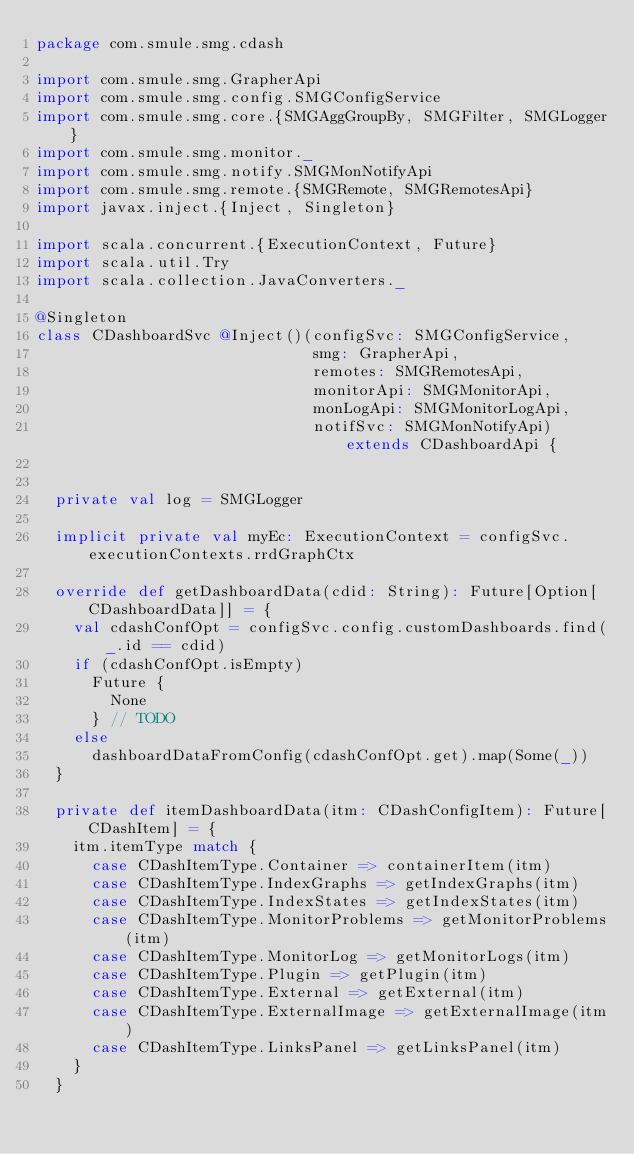Convert code to text. <code><loc_0><loc_0><loc_500><loc_500><_Scala_>package com.smule.smg.cdash

import com.smule.smg.GrapherApi
import com.smule.smg.config.SMGConfigService
import com.smule.smg.core.{SMGAggGroupBy, SMGFilter, SMGLogger}
import com.smule.smg.monitor._
import com.smule.smg.notify.SMGMonNotifyApi
import com.smule.smg.remote.{SMGRemote, SMGRemotesApi}
import javax.inject.{Inject, Singleton}

import scala.concurrent.{ExecutionContext, Future}
import scala.util.Try
import scala.collection.JavaConverters._

@Singleton
class CDashboardSvc @Inject()(configSvc: SMGConfigService,
                              smg: GrapherApi,
                              remotes: SMGRemotesApi,
                              monitorApi: SMGMonitorApi,
                              monLogApi: SMGMonitorLogApi,
                              notifSvc: SMGMonNotifyApi) extends CDashboardApi {


  private val log = SMGLogger

  implicit private val myEc: ExecutionContext = configSvc.executionContexts.rrdGraphCtx

  override def getDashboardData(cdid: String): Future[Option[CDashboardData]] = {
    val cdashConfOpt = configSvc.config.customDashboards.find(_.id == cdid)
    if (cdashConfOpt.isEmpty)
      Future {
        None
      } // TODO
    else
      dashboardDataFromConfig(cdashConfOpt.get).map(Some(_))
  }

  private def itemDashboardData(itm: CDashConfigItem): Future[CDashItem] = {
    itm.itemType match {
      case CDashItemType.Container => containerItem(itm)
      case CDashItemType.IndexGraphs => getIndexGraphs(itm)
      case CDashItemType.IndexStates => getIndexStates(itm)
      case CDashItemType.MonitorProblems => getMonitorProblems(itm)
      case CDashItemType.MonitorLog => getMonitorLogs(itm)
      case CDashItemType.Plugin => getPlugin(itm)
      case CDashItemType.External => getExternal(itm)
      case CDashItemType.ExternalImage => getExternalImage(itm)
      case CDashItemType.LinksPanel => getLinksPanel(itm)
    }
  }
</code> 